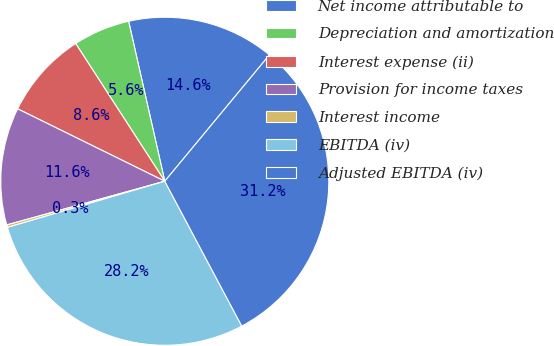Convert chart. <chart><loc_0><loc_0><loc_500><loc_500><pie_chart><fcel>Net income attributable to<fcel>Depreciation and amortization<fcel>Interest expense (ii)<fcel>Provision for income taxes<fcel>Interest income<fcel>EBITDA (iv)<fcel>Adjusted EBITDA (iv)<nl><fcel>14.55%<fcel>5.6%<fcel>8.58%<fcel>11.57%<fcel>0.25%<fcel>28.23%<fcel>31.21%<nl></chart> 